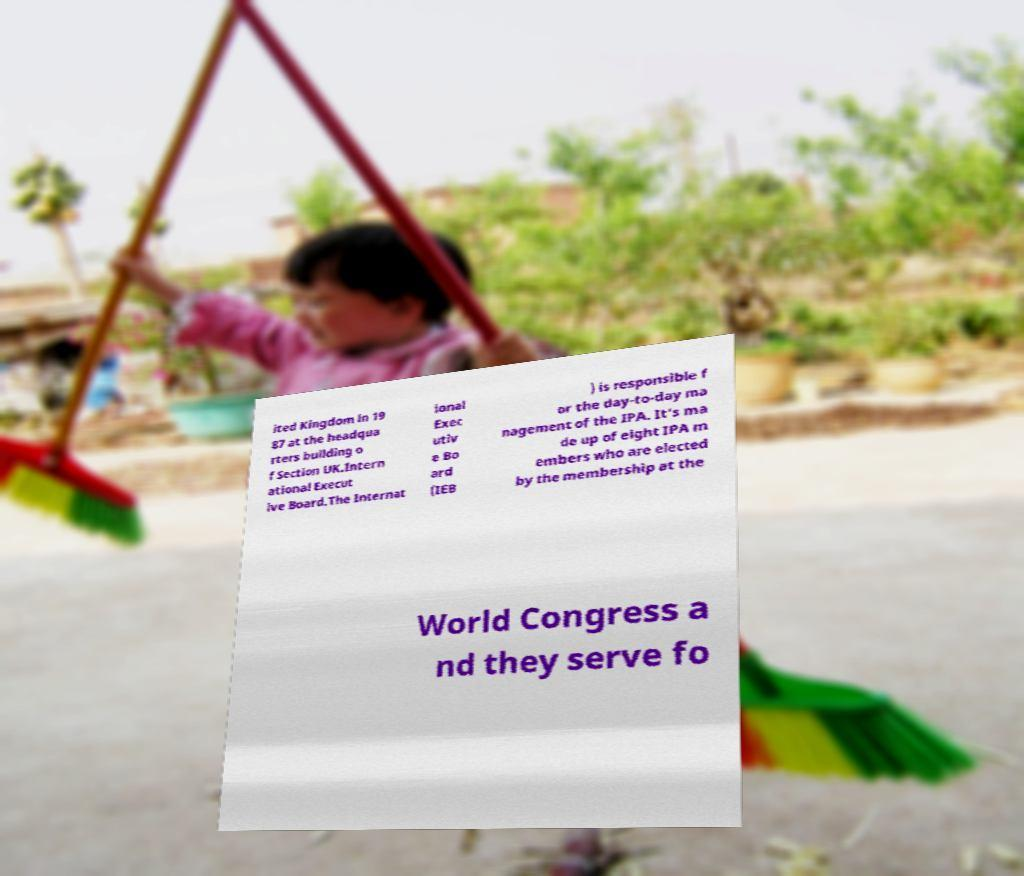There's text embedded in this image that I need extracted. Can you transcribe it verbatim? ited Kingdom in 19 87 at the headqua rters building o f Section UK.Intern ational Execut ive Board.The Internat ional Exec utiv e Bo ard (IEB ) is responsible f or the day-to-day ma nagement of the IPA. It's ma de up of eight IPA m embers who are elected by the membership at the World Congress a nd they serve fo 